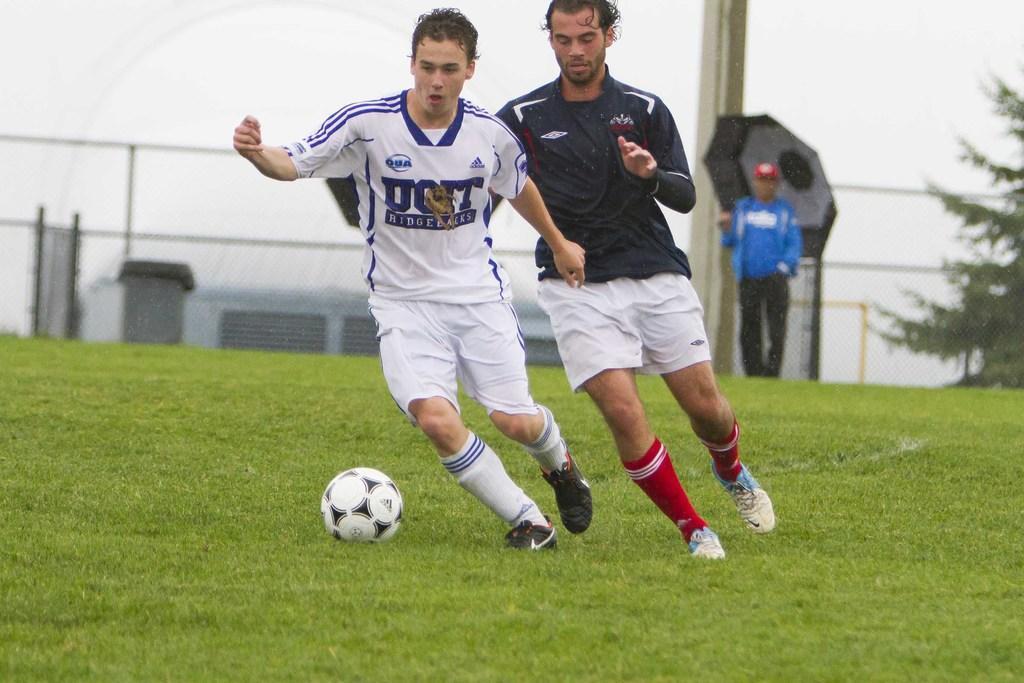Could you give a brief overview of what you see in this image? In this image I can see two persons playing football. I can see some grass on the ground. In the background I can see a person holding an umbrella. 